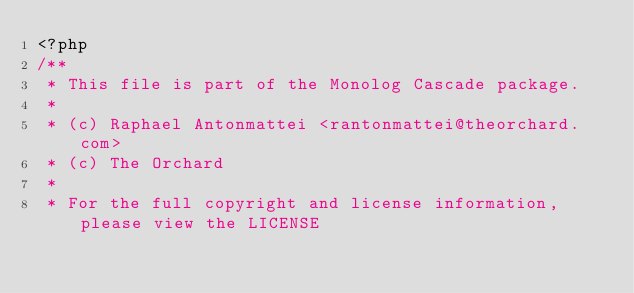Convert code to text. <code><loc_0><loc_0><loc_500><loc_500><_PHP_><?php
/**
 * This file is part of the Monolog Cascade package.
 *
 * (c) Raphael Antonmattei <rantonmattei@theorchard.com>
 * (c) The Orchard
 *
 * For the full copyright and license information, please view the LICENSE</code> 